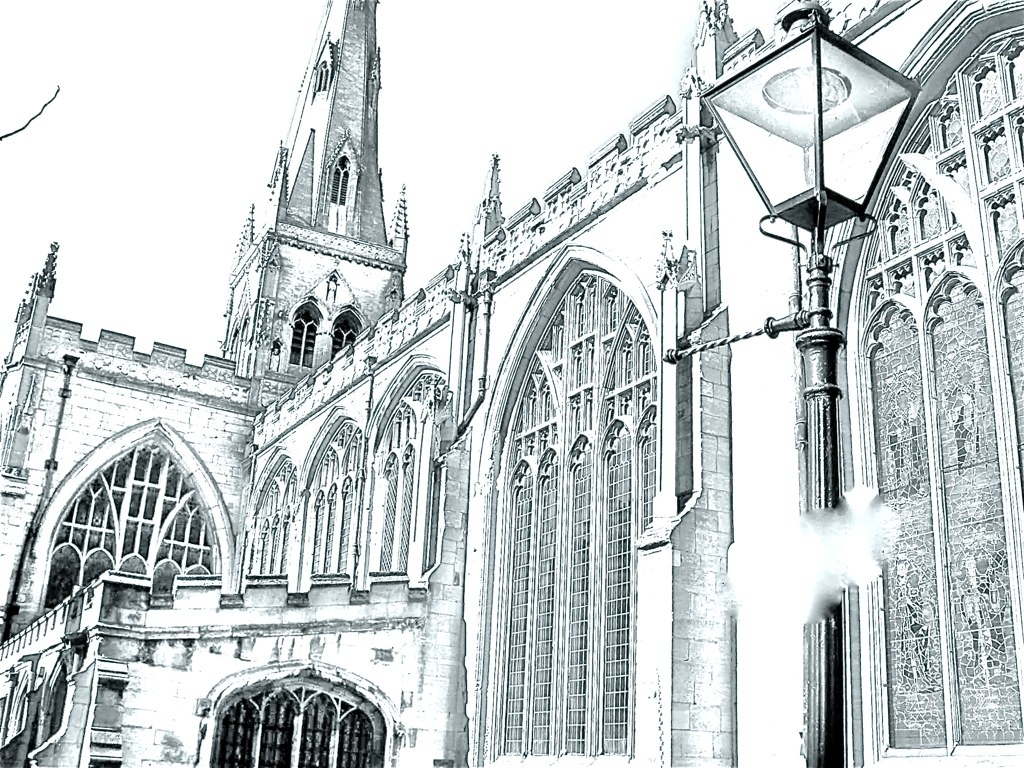Can you tell me about the architectural style of this building? The building in the image exhibits Gothic architectural characteristics, recognizable by its pointed arches, ribbed vaults, and flying buttresses. These elements were common in Europe from the 12th century onwards and were used to create awe-inspiring, light-filled structures. What can you deduce about the building's history and purpose? Gothic architecture was principally used for churches, cathedrals, and universities. Given the grandeur and detail of the building, it is likely a religious structure with a rich history, potentially serving as a central place of worship and community gatherings for many centuries. 